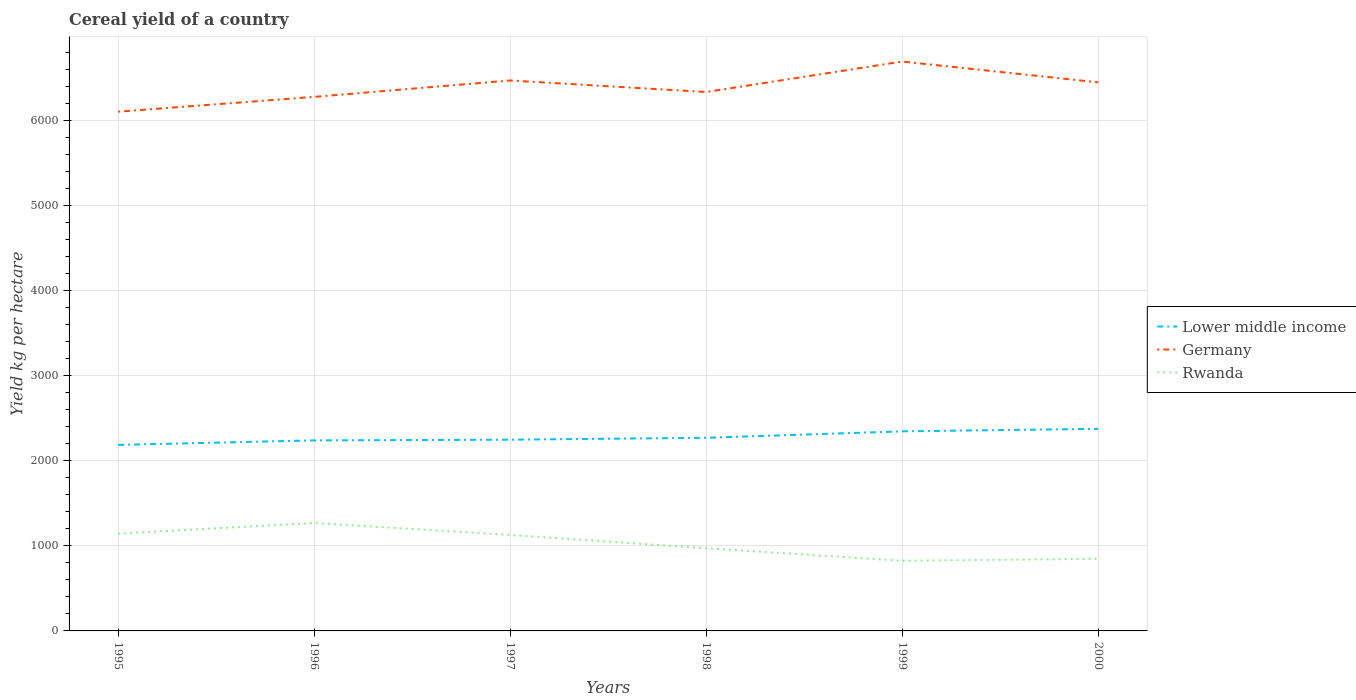Across all years, what is the maximum total cereal yield in Rwanda?
Your answer should be compact. 824.81. In which year was the total cereal yield in Lower middle income maximum?
Offer a very short reply. 1995. What is the total total cereal yield in Lower middle income in the graph?
Provide a succinct answer. -136.17. What is the difference between the highest and the second highest total cereal yield in Lower middle income?
Provide a short and direct response. 189.09. What is the difference between the highest and the lowest total cereal yield in Germany?
Keep it short and to the point. 3. How many years are there in the graph?
Your answer should be compact. 6. What is the title of the graph?
Provide a short and direct response. Cereal yield of a country. What is the label or title of the Y-axis?
Your answer should be very brief. Yield kg per hectare. What is the Yield kg per hectare of Lower middle income in 1995?
Provide a short and direct response. 2188.25. What is the Yield kg per hectare of Germany in 1995?
Make the answer very short. 6107.68. What is the Yield kg per hectare of Rwanda in 1995?
Your response must be concise. 1145.3. What is the Yield kg per hectare of Lower middle income in 1996?
Offer a very short reply. 2241.17. What is the Yield kg per hectare in Germany in 1996?
Your response must be concise. 6281.85. What is the Yield kg per hectare of Rwanda in 1996?
Your answer should be very brief. 1269.98. What is the Yield kg per hectare in Lower middle income in 1997?
Keep it short and to the point. 2249.47. What is the Yield kg per hectare in Germany in 1997?
Keep it short and to the point. 6474.95. What is the Yield kg per hectare of Rwanda in 1997?
Give a very brief answer. 1129.12. What is the Yield kg per hectare in Lower middle income in 1998?
Your answer should be compact. 2271.88. What is the Yield kg per hectare in Germany in 1998?
Give a very brief answer. 6339.19. What is the Yield kg per hectare of Rwanda in 1998?
Your response must be concise. 972.61. What is the Yield kg per hectare in Lower middle income in 1999?
Offer a very short reply. 2347.63. What is the Yield kg per hectare in Germany in 1999?
Make the answer very short. 6697.68. What is the Yield kg per hectare in Rwanda in 1999?
Keep it short and to the point. 824.81. What is the Yield kg per hectare of Lower middle income in 2000?
Ensure brevity in your answer.  2377.34. What is the Yield kg per hectare of Germany in 2000?
Your response must be concise. 6452.88. What is the Yield kg per hectare of Rwanda in 2000?
Provide a succinct answer. 848.34. Across all years, what is the maximum Yield kg per hectare in Lower middle income?
Make the answer very short. 2377.34. Across all years, what is the maximum Yield kg per hectare of Germany?
Ensure brevity in your answer.  6697.68. Across all years, what is the maximum Yield kg per hectare in Rwanda?
Provide a succinct answer. 1269.98. Across all years, what is the minimum Yield kg per hectare of Lower middle income?
Give a very brief answer. 2188.25. Across all years, what is the minimum Yield kg per hectare in Germany?
Provide a succinct answer. 6107.68. Across all years, what is the minimum Yield kg per hectare of Rwanda?
Your answer should be very brief. 824.81. What is the total Yield kg per hectare of Lower middle income in the graph?
Your answer should be compact. 1.37e+04. What is the total Yield kg per hectare in Germany in the graph?
Provide a succinct answer. 3.84e+04. What is the total Yield kg per hectare of Rwanda in the graph?
Your answer should be very brief. 6190.16. What is the difference between the Yield kg per hectare in Lower middle income in 1995 and that in 1996?
Your response must be concise. -52.91. What is the difference between the Yield kg per hectare of Germany in 1995 and that in 1996?
Provide a succinct answer. -174.17. What is the difference between the Yield kg per hectare of Rwanda in 1995 and that in 1996?
Give a very brief answer. -124.68. What is the difference between the Yield kg per hectare of Lower middle income in 1995 and that in 1997?
Provide a short and direct response. -61.22. What is the difference between the Yield kg per hectare in Germany in 1995 and that in 1997?
Make the answer very short. -367.28. What is the difference between the Yield kg per hectare in Rwanda in 1995 and that in 1997?
Your answer should be very brief. 16.18. What is the difference between the Yield kg per hectare in Lower middle income in 1995 and that in 1998?
Keep it short and to the point. -83.63. What is the difference between the Yield kg per hectare of Germany in 1995 and that in 1998?
Your response must be concise. -231.51. What is the difference between the Yield kg per hectare of Rwanda in 1995 and that in 1998?
Give a very brief answer. 172.69. What is the difference between the Yield kg per hectare of Lower middle income in 1995 and that in 1999?
Offer a very short reply. -159.38. What is the difference between the Yield kg per hectare of Germany in 1995 and that in 1999?
Make the answer very short. -590. What is the difference between the Yield kg per hectare in Rwanda in 1995 and that in 1999?
Your answer should be very brief. 320.49. What is the difference between the Yield kg per hectare of Lower middle income in 1995 and that in 2000?
Keep it short and to the point. -189.09. What is the difference between the Yield kg per hectare of Germany in 1995 and that in 2000?
Make the answer very short. -345.2. What is the difference between the Yield kg per hectare of Rwanda in 1995 and that in 2000?
Make the answer very short. 296.96. What is the difference between the Yield kg per hectare in Lower middle income in 1996 and that in 1997?
Make the answer very short. -8.3. What is the difference between the Yield kg per hectare of Germany in 1996 and that in 1997?
Offer a terse response. -193.11. What is the difference between the Yield kg per hectare of Rwanda in 1996 and that in 1997?
Your answer should be very brief. 140.87. What is the difference between the Yield kg per hectare of Lower middle income in 1996 and that in 1998?
Provide a short and direct response. -30.71. What is the difference between the Yield kg per hectare in Germany in 1996 and that in 1998?
Make the answer very short. -57.34. What is the difference between the Yield kg per hectare in Rwanda in 1996 and that in 1998?
Your answer should be compact. 297.37. What is the difference between the Yield kg per hectare of Lower middle income in 1996 and that in 1999?
Provide a succinct answer. -106.47. What is the difference between the Yield kg per hectare in Germany in 1996 and that in 1999?
Offer a terse response. -415.83. What is the difference between the Yield kg per hectare of Rwanda in 1996 and that in 1999?
Your answer should be very brief. 445.17. What is the difference between the Yield kg per hectare in Lower middle income in 1996 and that in 2000?
Keep it short and to the point. -136.17. What is the difference between the Yield kg per hectare in Germany in 1996 and that in 2000?
Provide a short and direct response. -171.03. What is the difference between the Yield kg per hectare in Rwanda in 1996 and that in 2000?
Keep it short and to the point. 421.64. What is the difference between the Yield kg per hectare of Lower middle income in 1997 and that in 1998?
Your answer should be compact. -22.41. What is the difference between the Yield kg per hectare in Germany in 1997 and that in 1998?
Provide a succinct answer. 135.76. What is the difference between the Yield kg per hectare of Rwanda in 1997 and that in 1998?
Provide a succinct answer. 156.5. What is the difference between the Yield kg per hectare in Lower middle income in 1997 and that in 1999?
Your response must be concise. -98.16. What is the difference between the Yield kg per hectare of Germany in 1997 and that in 1999?
Give a very brief answer. -222.72. What is the difference between the Yield kg per hectare of Rwanda in 1997 and that in 1999?
Give a very brief answer. 304.31. What is the difference between the Yield kg per hectare in Lower middle income in 1997 and that in 2000?
Make the answer very short. -127.87. What is the difference between the Yield kg per hectare in Germany in 1997 and that in 2000?
Ensure brevity in your answer.  22.07. What is the difference between the Yield kg per hectare of Rwanda in 1997 and that in 2000?
Your response must be concise. 280.77. What is the difference between the Yield kg per hectare in Lower middle income in 1998 and that in 1999?
Ensure brevity in your answer.  -75.75. What is the difference between the Yield kg per hectare in Germany in 1998 and that in 1999?
Offer a terse response. -358.49. What is the difference between the Yield kg per hectare in Rwanda in 1998 and that in 1999?
Ensure brevity in your answer.  147.81. What is the difference between the Yield kg per hectare in Lower middle income in 1998 and that in 2000?
Your answer should be very brief. -105.46. What is the difference between the Yield kg per hectare of Germany in 1998 and that in 2000?
Your answer should be very brief. -113.69. What is the difference between the Yield kg per hectare in Rwanda in 1998 and that in 2000?
Offer a very short reply. 124.27. What is the difference between the Yield kg per hectare in Lower middle income in 1999 and that in 2000?
Give a very brief answer. -29.7. What is the difference between the Yield kg per hectare in Germany in 1999 and that in 2000?
Your response must be concise. 244.8. What is the difference between the Yield kg per hectare in Rwanda in 1999 and that in 2000?
Offer a very short reply. -23.53. What is the difference between the Yield kg per hectare of Lower middle income in 1995 and the Yield kg per hectare of Germany in 1996?
Your answer should be very brief. -4093.59. What is the difference between the Yield kg per hectare in Lower middle income in 1995 and the Yield kg per hectare in Rwanda in 1996?
Your answer should be very brief. 918.27. What is the difference between the Yield kg per hectare of Germany in 1995 and the Yield kg per hectare of Rwanda in 1996?
Give a very brief answer. 4837.69. What is the difference between the Yield kg per hectare in Lower middle income in 1995 and the Yield kg per hectare in Germany in 1997?
Offer a very short reply. -4286.7. What is the difference between the Yield kg per hectare of Lower middle income in 1995 and the Yield kg per hectare of Rwanda in 1997?
Offer a terse response. 1059.14. What is the difference between the Yield kg per hectare in Germany in 1995 and the Yield kg per hectare in Rwanda in 1997?
Give a very brief answer. 4978.56. What is the difference between the Yield kg per hectare of Lower middle income in 1995 and the Yield kg per hectare of Germany in 1998?
Offer a terse response. -4150.94. What is the difference between the Yield kg per hectare in Lower middle income in 1995 and the Yield kg per hectare in Rwanda in 1998?
Provide a succinct answer. 1215.64. What is the difference between the Yield kg per hectare of Germany in 1995 and the Yield kg per hectare of Rwanda in 1998?
Your response must be concise. 5135.06. What is the difference between the Yield kg per hectare of Lower middle income in 1995 and the Yield kg per hectare of Germany in 1999?
Ensure brevity in your answer.  -4509.42. What is the difference between the Yield kg per hectare of Lower middle income in 1995 and the Yield kg per hectare of Rwanda in 1999?
Give a very brief answer. 1363.45. What is the difference between the Yield kg per hectare of Germany in 1995 and the Yield kg per hectare of Rwanda in 1999?
Your response must be concise. 5282.87. What is the difference between the Yield kg per hectare of Lower middle income in 1995 and the Yield kg per hectare of Germany in 2000?
Offer a terse response. -4264.63. What is the difference between the Yield kg per hectare in Lower middle income in 1995 and the Yield kg per hectare in Rwanda in 2000?
Keep it short and to the point. 1339.91. What is the difference between the Yield kg per hectare in Germany in 1995 and the Yield kg per hectare in Rwanda in 2000?
Your answer should be compact. 5259.33. What is the difference between the Yield kg per hectare in Lower middle income in 1996 and the Yield kg per hectare in Germany in 1997?
Your response must be concise. -4233.79. What is the difference between the Yield kg per hectare of Lower middle income in 1996 and the Yield kg per hectare of Rwanda in 1997?
Provide a short and direct response. 1112.05. What is the difference between the Yield kg per hectare in Germany in 1996 and the Yield kg per hectare in Rwanda in 1997?
Give a very brief answer. 5152.73. What is the difference between the Yield kg per hectare of Lower middle income in 1996 and the Yield kg per hectare of Germany in 1998?
Offer a terse response. -4098.02. What is the difference between the Yield kg per hectare in Lower middle income in 1996 and the Yield kg per hectare in Rwanda in 1998?
Ensure brevity in your answer.  1268.55. What is the difference between the Yield kg per hectare in Germany in 1996 and the Yield kg per hectare in Rwanda in 1998?
Give a very brief answer. 5309.23. What is the difference between the Yield kg per hectare of Lower middle income in 1996 and the Yield kg per hectare of Germany in 1999?
Keep it short and to the point. -4456.51. What is the difference between the Yield kg per hectare in Lower middle income in 1996 and the Yield kg per hectare in Rwanda in 1999?
Your response must be concise. 1416.36. What is the difference between the Yield kg per hectare of Germany in 1996 and the Yield kg per hectare of Rwanda in 1999?
Offer a very short reply. 5457.04. What is the difference between the Yield kg per hectare of Lower middle income in 1996 and the Yield kg per hectare of Germany in 2000?
Your response must be concise. -4211.71. What is the difference between the Yield kg per hectare of Lower middle income in 1996 and the Yield kg per hectare of Rwanda in 2000?
Provide a succinct answer. 1392.83. What is the difference between the Yield kg per hectare in Germany in 1996 and the Yield kg per hectare in Rwanda in 2000?
Keep it short and to the point. 5433.51. What is the difference between the Yield kg per hectare of Lower middle income in 1997 and the Yield kg per hectare of Germany in 1998?
Your answer should be very brief. -4089.72. What is the difference between the Yield kg per hectare in Lower middle income in 1997 and the Yield kg per hectare in Rwanda in 1998?
Provide a succinct answer. 1276.86. What is the difference between the Yield kg per hectare of Germany in 1997 and the Yield kg per hectare of Rwanda in 1998?
Offer a very short reply. 5502.34. What is the difference between the Yield kg per hectare of Lower middle income in 1997 and the Yield kg per hectare of Germany in 1999?
Make the answer very short. -4448.21. What is the difference between the Yield kg per hectare in Lower middle income in 1997 and the Yield kg per hectare in Rwanda in 1999?
Give a very brief answer. 1424.66. What is the difference between the Yield kg per hectare in Germany in 1997 and the Yield kg per hectare in Rwanda in 1999?
Ensure brevity in your answer.  5650.15. What is the difference between the Yield kg per hectare of Lower middle income in 1997 and the Yield kg per hectare of Germany in 2000?
Your answer should be compact. -4203.41. What is the difference between the Yield kg per hectare of Lower middle income in 1997 and the Yield kg per hectare of Rwanda in 2000?
Keep it short and to the point. 1401.13. What is the difference between the Yield kg per hectare of Germany in 1997 and the Yield kg per hectare of Rwanda in 2000?
Make the answer very short. 5626.61. What is the difference between the Yield kg per hectare in Lower middle income in 1998 and the Yield kg per hectare in Germany in 1999?
Keep it short and to the point. -4425.8. What is the difference between the Yield kg per hectare in Lower middle income in 1998 and the Yield kg per hectare in Rwanda in 1999?
Give a very brief answer. 1447.07. What is the difference between the Yield kg per hectare in Germany in 1998 and the Yield kg per hectare in Rwanda in 1999?
Keep it short and to the point. 5514.38. What is the difference between the Yield kg per hectare in Lower middle income in 1998 and the Yield kg per hectare in Germany in 2000?
Ensure brevity in your answer.  -4181. What is the difference between the Yield kg per hectare in Lower middle income in 1998 and the Yield kg per hectare in Rwanda in 2000?
Ensure brevity in your answer.  1423.54. What is the difference between the Yield kg per hectare of Germany in 1998 and the Yield kg per hectare of Rwanda in 2000?
Offer a terse response. 5490.85. What is the difference between the Yield kg per hectare in Lower middle income in 1999 and the Yield kg per hectare in Germany in 2000?
Ensure brevity in your answer.  -4105.25. What is the difference between the Yield kg per hectare of Lower middle income in 1999 and the Yield kg per hectare of Rwanda in 2000?
Ensure brevity in your answer.  1499.29. What is the difference between the Yield kg per hectare of Germany in 1999 and the Yield kg per hectare of Rwanda in 2000?
Your response must be concise. 5849.34. What is the average Yield kg per hectare of Lower middle income per year?
Provide a succinct answer. 2279.29. What is the average Yield kg per hectare in Germany per year?
Keep it short and to the point. 6392.37. What is the average Yield kg per hectare of Rwanda per year?
Give a very brief answer. 1031.69. In the year 1995, what is the difference between the Yield kg per hectare in Lower middle income and Yield kg per hectare in Germany?
Keep it short and to the point. -3919.42. In the year 1995, what is the difference between the Yield kg per hectare of Lower middle income and Yield kg per hectare of Rwanda?
Provide a succinct answer. 1042.96. In the year 1995, what is the difference between the Yield kg per hectare in Germany and Yield kg per hectare in Rwanda?
Offer a very short reply. 4962.38. In the year 1996, what is the difference between the Yield kg per hectare of Lower middle income and Yield kg per hectare of Germany?
Your answer should be compact. -4040.68. In the year 1996, what is the difference between the Yield kg per hectare in Lower middle income and Yield kg per hectare in Rwanda?
Your answer should be very brief. 971.19. In the year 1996, what is the difference between the Yield kg per hectare of Germany and Yield kg per hectare of Rwanda?
Your answer should be very brief. 5011.86. In the year 1997, what is the difference between the Yield kg per hectare of Lower middle income and Yield kg per hectare of Germany?
Your answer should be very brief. -4225.48. In the year 1997, what is the difference between the Yield kg per hectare of Lower middle income and Yield kg per hectare of Rwanda?
Provide a short and direct response. 1120.35. In the year 1997, what is the difference between the Yield kg per hectare in Germany and Yield kg per hectare in Rwanda?
Keep it short and to the point. 5345.84. In the year 1998, what is the difference between the Yield kg per hectare in Lower middle income and Yield kg per hectare in Germany?
Offer a terse response. -4067.31. In the year 1998, what is the difference between the Yield kg per hectare in Lower middle income and Yield kg per hectare in Rwanda?
Keep it short and to the point. 1299.27. In the year 1998, what is the difference between the Yield kg per hectare of Germany and Yield kg per hectare of Rwanda?
Ensure brevity in your answer.  5366.58. In the year 1999, what is the difference between the Yield kg per hectare of Lower middle income and Yield kg per hectare of Germany?
Keep it short and to the point. -4350.04. In the year 1999, what is the difference between the Yield kg per hectare of Lower middle income and Yield kg per hectare of Rwanda?
Keep it short and to the point. 1522.83. In the year 1999, what is the difference between the Yield kg per hectare in Germany and Yield kg per hectare in Rwanda?
Make the answer very short. 5872.87. In the year 2000, what is the difference between the Yield kg per hectare in Lower middle income and Yield kg per hectare in Germany?
Make the answer very short. -4075.54. In the year 2000, what is the difference between the Yield kg per hectare in Lower middle income and Yield kg per hectare in Rwanda?
Offer a terse response. 1529. In the year 2000, what is the difference between the Yield kg per hectare in Germany and Yield kg per hectare in Rwanda?
Make the answer very short. 5604.54. What is the ratio of the Yield kg per hectare of Lower middle income in 1995 to that in 1996?
Provide a succinct answer. 0.98. What is the ratio of the Yield kg per hectare of Germany in 1995 to that in 1996?
Make the answer very short. 0.97. What is the ratio of the Yield kg per hectare of Rwanda in 1995 to that in 1996?
Make the answer very short. 0.9. What is the ratio of the Yield kg per hectare in Lower middle income in 1995 to that in 1997?
Ensure brevity in your answer.  0.97. What is the ratio of the Yield kg per hectare in Germany in 1995 to that in 1997?
Keep it short and to the point. 0.94. What is the ratio of the Yield kg per hectare of Rwanda in 1995 to that in 1997?
Provide a short and direct response. 1.01. What is the ratio of the Yield kg per hectare in Lower middle income in 1995 to that in 1998?
Offer a very short reply. 0.96. What is the ratio of the Yield kg per hectare of Germany in 1995 to that in 1998?
Give a very brief answer. 0.96. What is the ratio of the Yield kg per hectare in Rwanda in 1995 to that in 1998?
Provide a succinct answer. 1.18. What is the ratio of the Yield kg per hectare of Lower middle income in 1995 to that in 1999?
Make the answer very short. 0.93. What is the ratio of the Yield kg per hectare in Germany in 1995 to that in 1999?
Your answer should be compact. 0.91. What is the ratio of the Yield kg per hectare in Rwanda in 1995 to that in 1999?
Provide a short and direct response. 1.39. What is the ratio of the Yield kg per hectare of Lower middle income in 1995 to that in 2000?
Your response must be concise. 0.92. What is the ratio of the Yield kg per hectare in Germany in 1995 to that in 2000?
Your answer should be very brief. 0.95. What is the ratio of the Yield kg per hectare in Rwanda in 1995 to that in 2000?
Your response must be concise. 1.35. What is the ratio of the Yield kg per hectare in Lower middle income in 1996 to that in 1997?
Offer a very short reply. 1. What is the ratio of the Yield kg per hectare in Germany in 1996 to that in 1997?
Ensure brevity in your answer.  0.97. What is the ratio of the Yield kg per hectare in Rwanda in 1996 to that in 1997?
Your answer should be compact. 1.12. What is the ratio of the Yield kg per hectare of Lower middle income in 1996 to that in 1998?
Your answer should be compact. 0.99. What is the ratio of the Yield kg per hectare of Germany in 1996 to that in 1998?
Provide a short and direct response. 0.99. What is the ratio of the Yield kg per hectare in Rwanda in 1996 to that in 1998?
Keep it short and to the point. 1.31. What is the ratio of the Yield kg per hectare of Lower middle income in 1996 to that in 1999?
Make the answer very short. 0.95. What is the ratio of the Yield kg per hectare in Germany in 1996 to that in 1999?
Your answer should be very brief. 0.94. What is the ratio of the Yield kg per hectare of Rwanda in 1996 to that in 1999?
Keep it short and to the point. 1.54. What is the ratio of the Yield kg per hectare in Lower middle income in 1996 to that in 2000?
Make the answer very short. 0.94. What is the ratio of the Yield kg per hectare of Germany in 1996 to that in 2000?
Provide a short and direct response. 0.97. What is the ratio of the Yield kg per hectare in Rwanda in 1996 to that in 2000?
Offer a very short reply. 1.5. What is the ratio of the Yield kg per hectare in Germany in 1997 to that in 1998?
Make the answer very short. 1.02. What is the ratio of the Yield kg per hectare of Rwanda in 1997 to that in 1998?
Your answer should be very brief. 1.16. What is the ratio of the Yield kg per hectare in Lower middle income in 1997 to that in 1999?
Your answer should be compact. 0.96. What is the ratio of the Yield kg per hectare of Germany in 1997 to that in 1999?
Your answer should be compact. 0.97. What is the ratio of the Yield kg per hectare in Rwanda in 1997 to that in 1999?
Make the answer very short. 1.37. What is the ratio of the Yield kg per hectare in Lower middle income in 1997 to that in 2000?
Your answer should be very brief. 0.95. What is the ratio of the Yield kg per hectare in Germany in 1997 to that in 2000?
Provide a succinct answer. 1. What is the ratio of the Yield kg per hectare in Rwanda in 1997 to that in 2000?
Your answer should be very brief. 1.33. What is the ratio of the Yield kg per hectare of Germany in 1998 to that in 1999?
Ensure brevity in your answer.  0.95. What is the ratio of the Yield kg per hectare of Rwanda in 1998 to that in 1999?
Your response must be concise. 1.18. What is the ratio of the Yield kg per hectare of Lower middle income in 1998 to that in 2000?
Give a very brief answer. 0.96. What is the ratio of the Yield kg per hectare of Germany in 1998 to that in 2000?
Offer a very short reply. 0.98. What is the ratio of the Yield kg per hectare of Rwanda in 1998 to that in 2000?
Keep it short and to the point. 1.15. What is the ratio of the Yield kg per hectare in Lower middle income in 1999 to that in 2000?
Your answer should be very brief. 0.99. What is the ratio of the Yield kg per hectare of Germany in 1999 to that in 2000?
Keep it short and to the point. 1.04. What is the ratio of the Yield kg per hectare of Rwanda in 1999 to that in 2000?
Keep it short and to the point. 0.97. What is the difference between the highest and the second highest Yield kg per hectare in Lower middle income?
Offer a very short reply. 29.7. What is the difference between the highest and the second highest Yield kg per hectare of Germany?
Provide a succinct answer. 222.72. What is the difference between the highest and the second highest Yield kg per hectare of Rwanda?
Your answer should be compact. 124.68. What is the difference between the highest and the lowest Yield kg per hectare of Lower middle income?
Your answer should be very brief. 189.09. What is the difference between the highest and the lowest Yield kg per hectare in Germany?
Offer a very short reply. 590. What is the difference between the highest and the lowest Yield kg per hectare of Rwanda?
Your answer should be very brief. 445.17. 